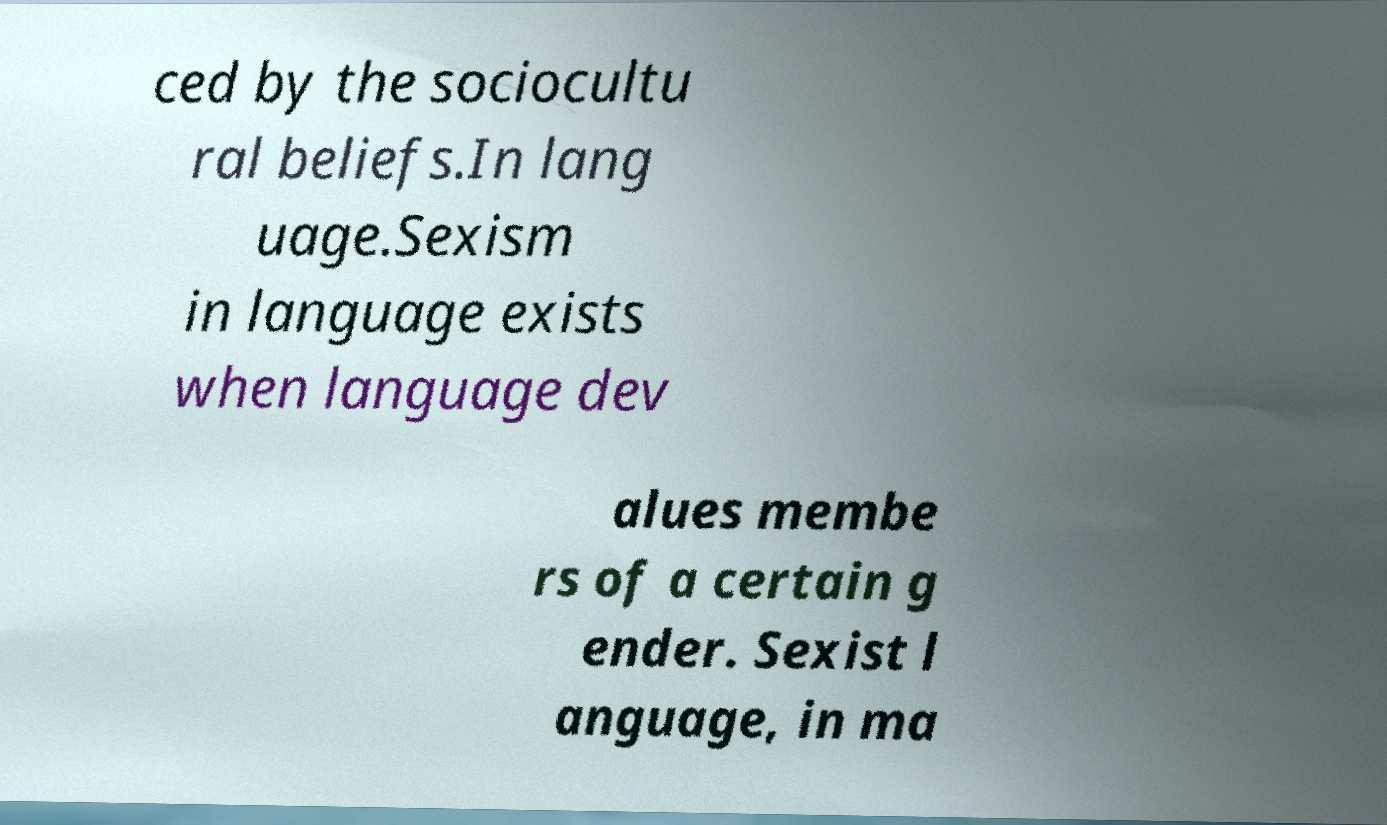Could you extract and type out the text from this image? ced by the sociocultu ral beliefs.In lang uage.Sexism in language exists when language dev alues membe rs of a certain g ender. Sexist l anguage, in ma 